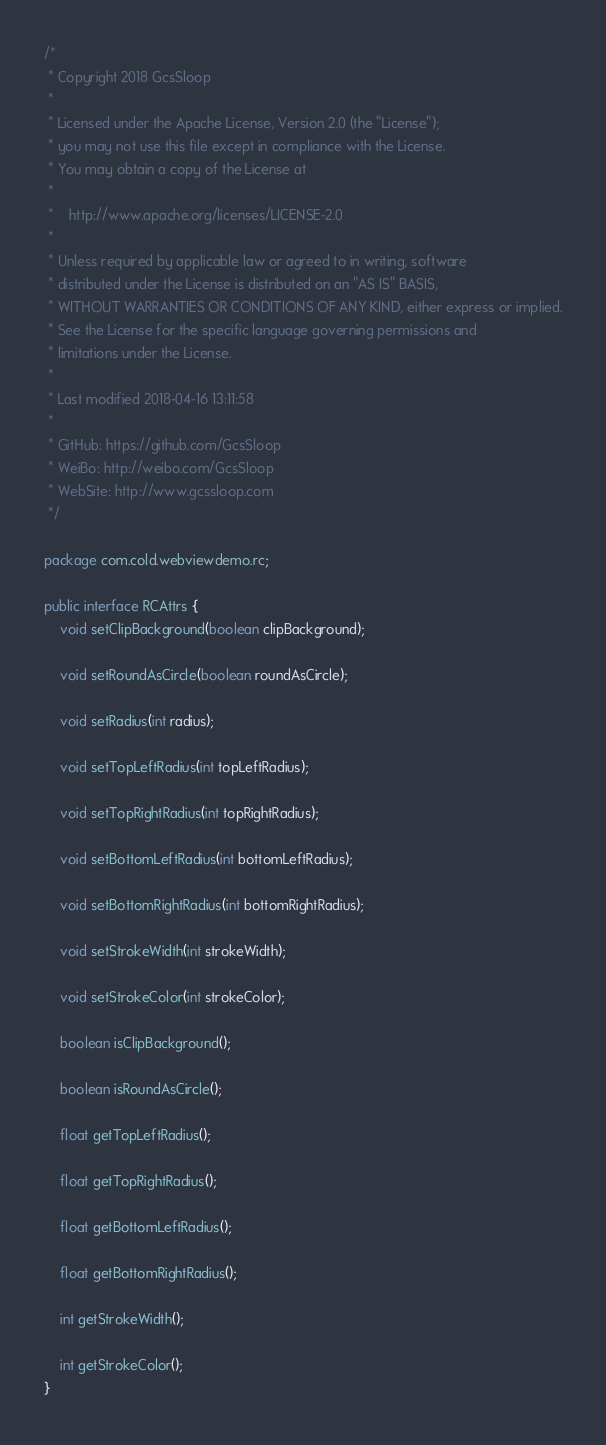Convert code to text. <code><loc_0><loc_0><loc_500><loc_500><_Java_>/*
 * Copyright 2018 GcsSloop
 *
 * Licensed under the Apache License, Version 2.0 (the "License");
 * you may not use this file except in compliance with the License.
 * You may obtain a copy of the License at
 *
 *    http://www.apache.org/licenses/LICENSE-2.0
 *
 * Unless required by applicable law or agreed to in writing, software
 * distributed under the License is distributed on an "AS IS" BASIS,
 * WITHOUT WARRANTIES OR CONDITIONS OF ANY KIND, either express or implied.
 * See the License for the specific language governing permissions and
 * limitations under the License.
 *
 * Last modified 2018-04-16 13:11:58
 *
 * GitHub: https://github.com/GcsSloop
 * WeiBo: http://weibo.com/GcsSloop
 * WebSite: http://www.gcssloop.com
 */

package com.cold.webviewdemo.rc;

public interface RCAttrs {
    void setClipBackground(boolean clipBackground);

    void setRoundAsCircle(boolean roundAsCircle);

    void setRadius(int radius);

    void setTopLeftRadius(int topLeftRadius);

    void setTopRightRadius(int topRightRadius);

    void setBottomLeftRadius(int bottomLeftRadius);

    void setBottomRightRadius(int bottomRightRadius);

    void setStrokeWidth(int strokeWidth);

    void setStrokeColor(int strokeColor);

    boolean isClipBackground();

    boolean isRoundAsCircle();

    float getTopLeftRadius();

    float getTopRightRadius();

    float getBottomLeftRadius();

    float getBottomRightRadius();

    int getStrokeWidth();

    int getStrokeColor();
}
</code> 